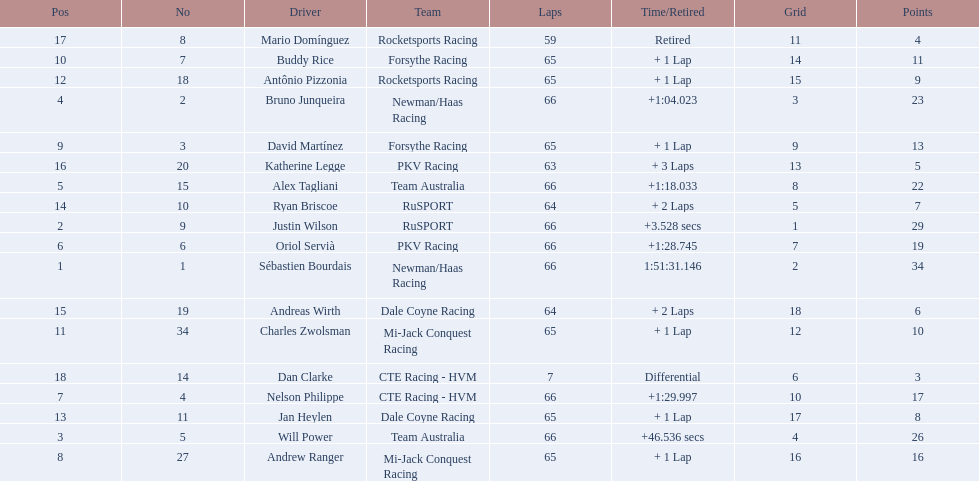Who finished directly after the driver who finished in 1:28.745? Nelson Philippe. 